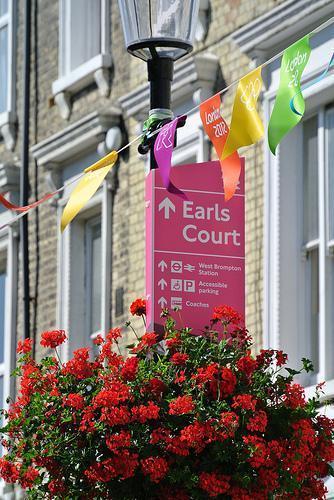How many flags are visible?
Give a very brief answer. 6. How many lamps can be seen?
Give a very brief answer. 1. How many flags are on the string?
Give a very brief answer. 6. 